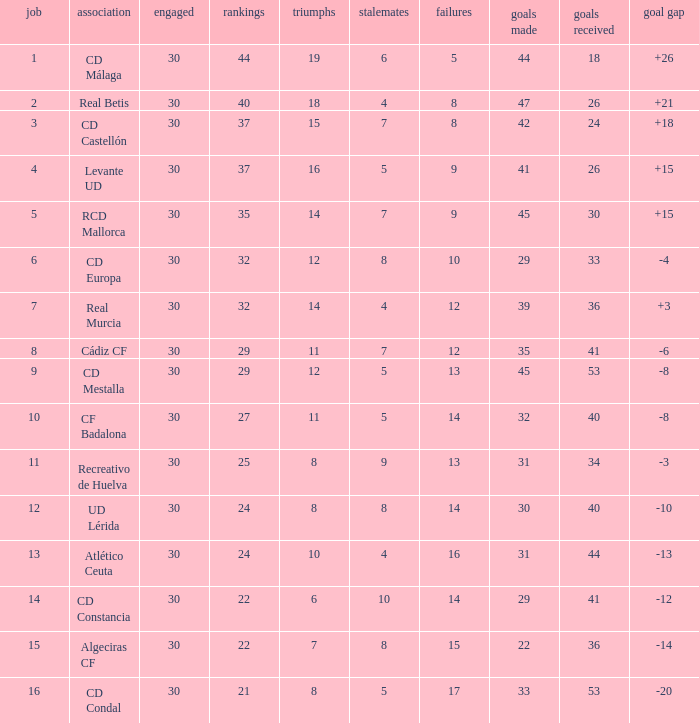What is the wins number when the points were smaller than 27, and goals against was 41? 6.0. 